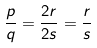<formula> <loc_0><loc_0><loc_500><loc_500>\frac { p } { q } = \frac { 2 r } { 2 s } = \frac { r } { s }</formula> 